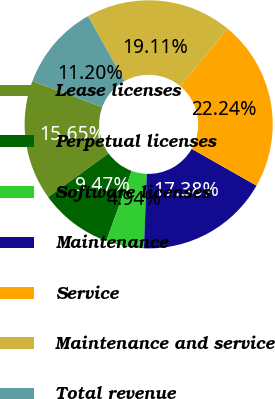<chart> <loc_0><loc_0><loc_500><loc_500><pie_chart><fcel>Lease licenses<fcel>Perpetual licenses<fcel>Software licenses<fcel>Maintenance<fcel>Service<fcel>Maintenance and service<fcel>Total revenue<nl><fcel>15.65%<fcel>9.47%<fcel>4.94%<fcel>17.38%<fcel>22.24%<fcel>19.11%<fcel>11.2%<nl></chart> 